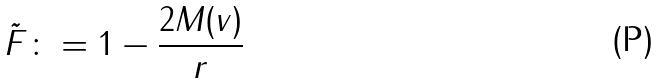<formula> <loc_0><loc_0><loc_500><loc_500>\tilde { F } \colon = 1 - \frac { 2 M ( v ) } { r }</formula> 